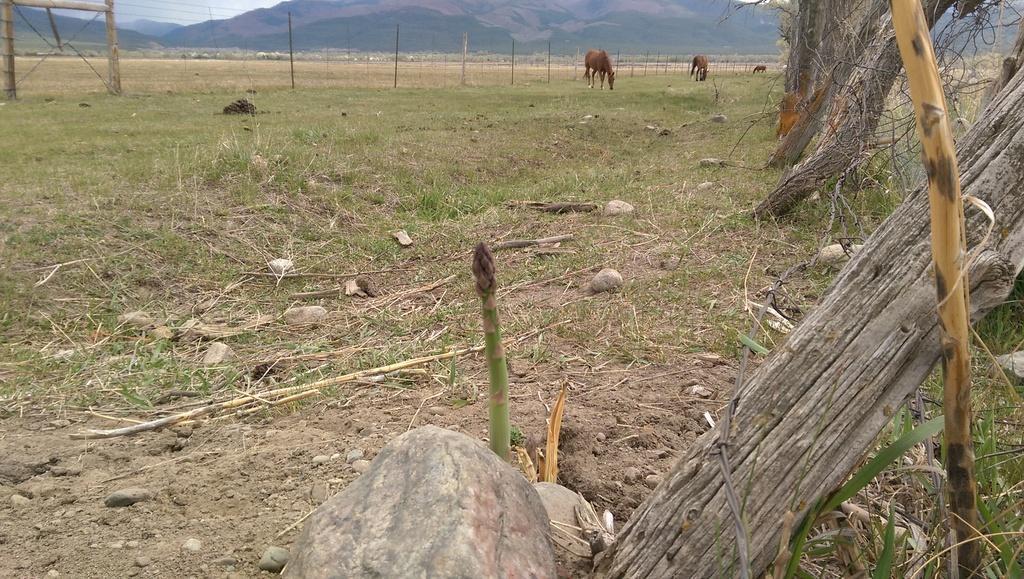In one or two sentences, can you explain what this image depicts? In this image there are animals and we can see logs. In the background there are hills and sky. We can see a fence. At the bottom there is grass. 